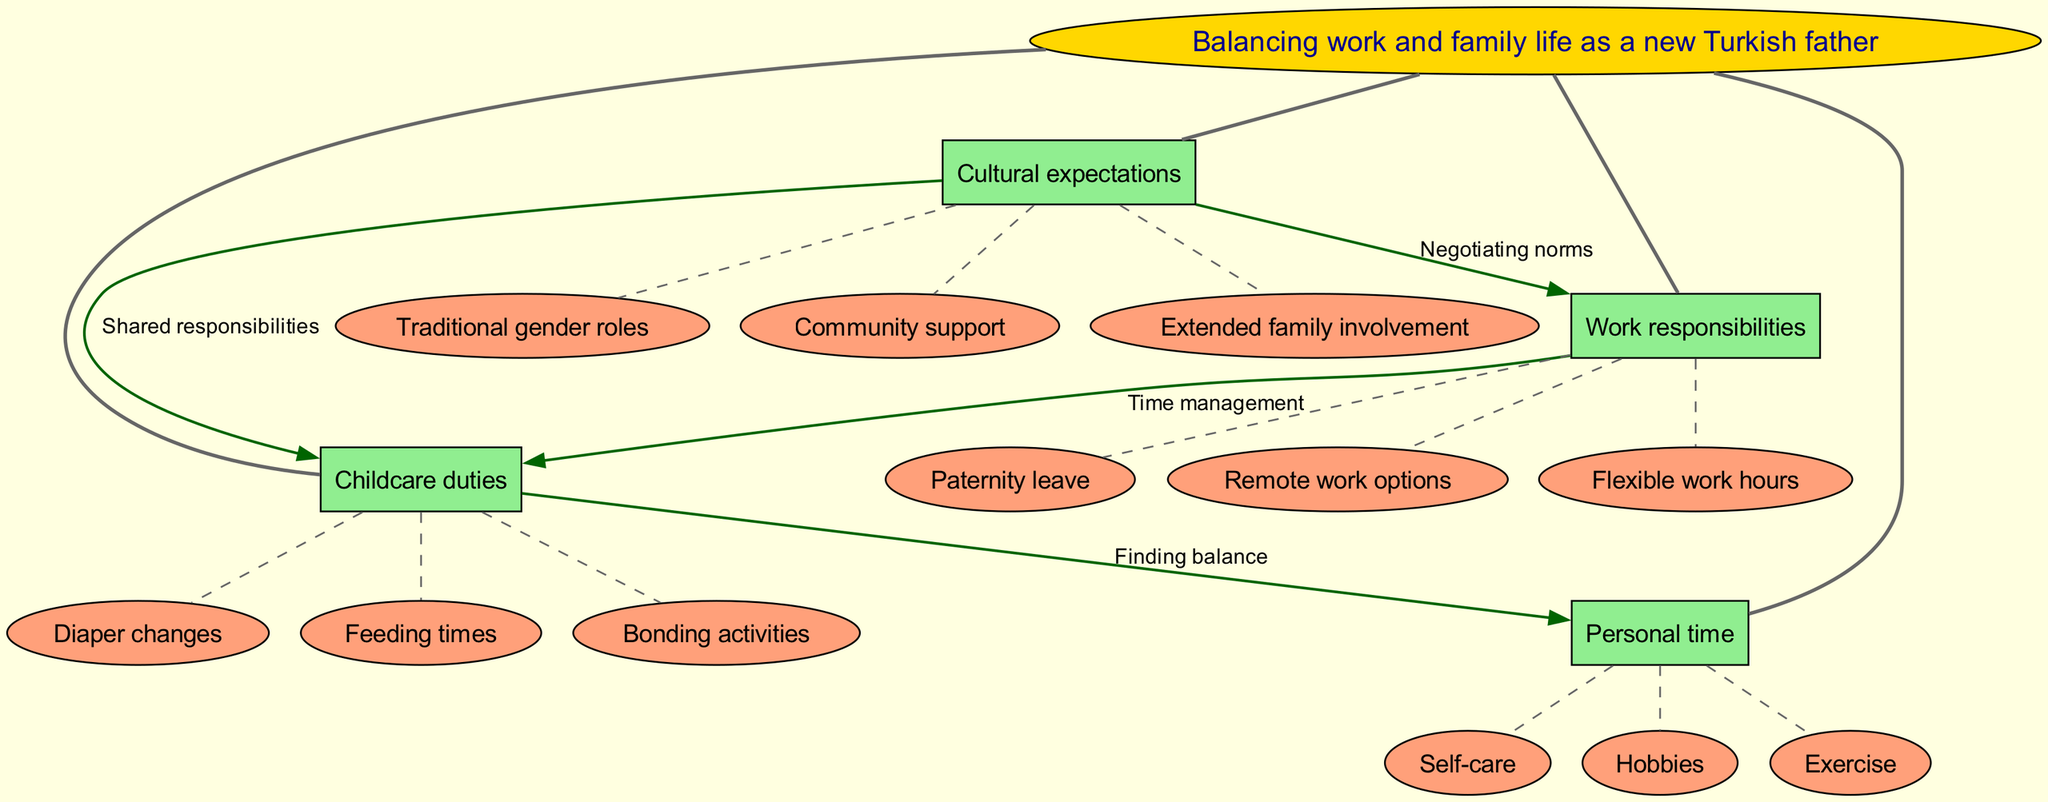What are the main nodes in the diagram? The main nodes are explicitly listed in the diagram, which includes "Work responsibilities," "Childcare duties," "Personal time," and "Cultural expectations." Since the question asks for the main nodes, I can directly refer to that list.
Answer: Work responsibilities, Childcare duties, Personal time, Cultural expectations How many sub-nodes are under "Work responsibilities"? The sub-nodes under "Work responsibilities" include "Flexible work hours," "Paternity leave," and "Remote work options." By counting these items, I determine that there are three sub-nodes under this main node.
Answer: 3 What label connects "Cultural expectations" to "Work responsibilities"? The diagram specifies the label for the connection between these two nodes, which is "Negotiating norms." I can locate this label directly on the connecting edge in the diagram.
Answer: Negotiating norms What is the relationship between "Childcare duties" and "Personal time"? The connection between "Childcare duties" and "Personal time" is labeled "Finding balance." This is shown as a directed edge in the diagram, clearly indicating the relationship between these two nodes.
Answer: Finding balance How many edges are there in total connecting the nodes? By examining the full structure of the diagram and counting all edges, both dashed and solid, I can calculate the total. The diagram details multiple connections, which adds up to a total of six edges linking the nodes together.
Answer: 6 Which node connects to "Extended family involvement"? "Extended family involvement" is a sub-node under "Cultural expectations." This link can be traced back as the sub-node of that particular main node in the diagram, confirming its position and association.
Answer: Cultural expectations What do the dashed edges signify in this diagram? Dashed edges are used in the diagram to denote the relationships between sub-nodes and their respective main nodes. This visual distinction helps identify the nature of those connections as more flexible or supportive in the context of the concept map.
Answer: Sub-node connections Which main node is related to both "Diaper changes" and "Feeding times"? Both "Diaper changes" and "Feeding times" are sub-nodes listed under "Childcare duties." I can identify that both share this common main node which reflects their relationship to childcare as a duty.
Answer: Childcare duties What color represents the edges that connect the nodes? The edges connecting the nodes in the diagram are described as being dark green in color. This detail can be noted directly from the visual attributes specified for the diagram edges.
Answer: Dark green 